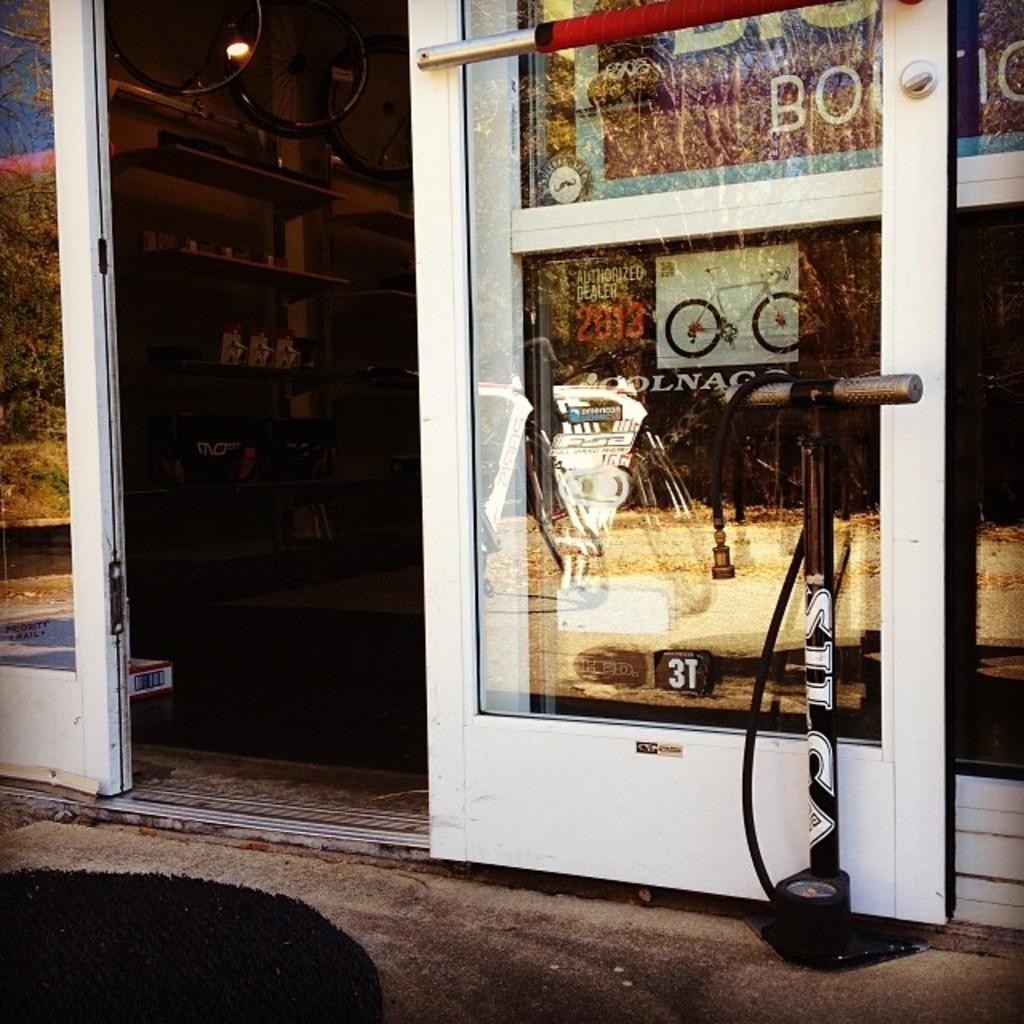What type of establishment is depicted in the image? The image is of a store. Can you describe a specific feature of the store? There is a door in the image. What might be used to display items in the store? There are racks in the image. What is a feature that provides illumination in the store? There is a light in the image. What can be found within the store? There are objects in the image. What type of waste is being disposed of in the store's waste bin in the image? There is no waste bin or waste present in the image. What invention is being demonstrated by the store's employees in the image? There is no invention or demonstration taking place in the image. 